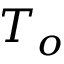<formula> <loc_0><loc_0><loc_500><loc_500>T _ { o }</formula> 